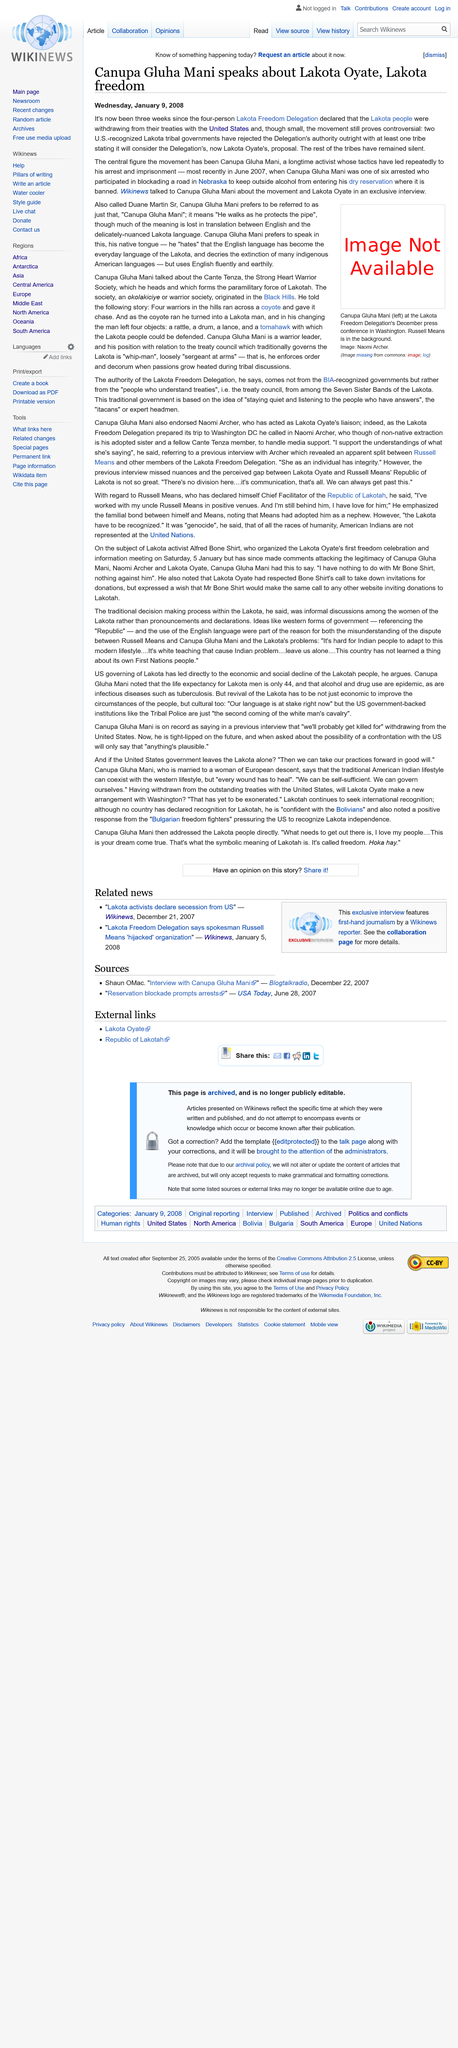Specify some key components in this picture. Canupa Gluha Mani spoke to Wikinews about the Lakota Oyate. On December 2007, the Lakota Freedom Delegation announced their withdrawal from treaties with the United States. A total of six individuals were arrested in June 2007 for participating in a road blockade. 